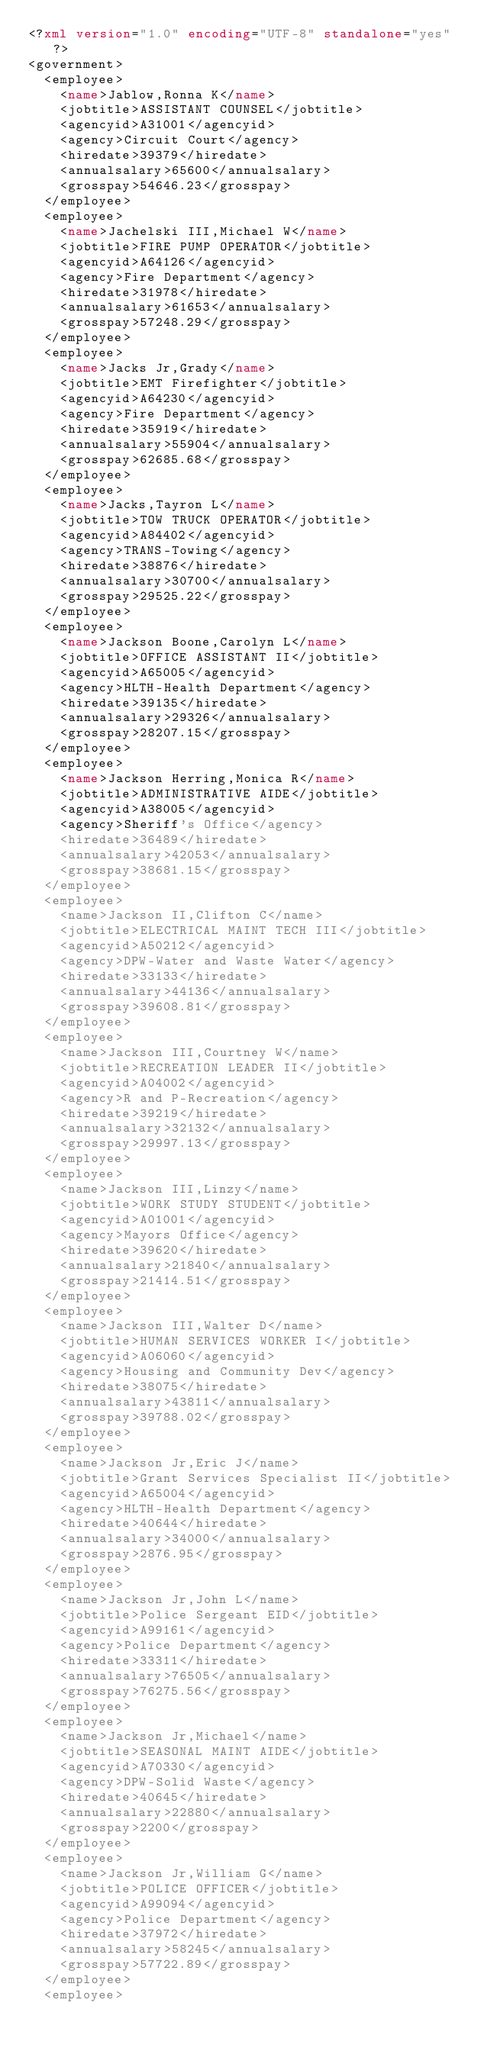Convert code to text. <code><loc_0><loc_0><loc_500><loc_500><_XML_><?xml version="1.0" encoding="UTF-8" standalone="yes"?>
<government>
	<employee>
		<name>Jablow,Ronna K</name>
		<jobtitle>ASSISTANT COUNSEL</jobtitle>
		<agencyid>A31001</agencyid>
		<agency>Circuit Court</agency>
		<hiredate>39379</hiredate>
		<annualsalary>65600</annualsalary>
		<grosspay>54646.23</grosspay>
	</employee>
	<employee>
		<name>Jachelski III,Michael W</name>
		<jobtitle>FIRE PUMP OPERATOR</jobtitle>
		<agencyid>A64126</agencyid>
		<agency>Fire Department</agency>
		<hiredate>31978</hiredate>
		<annualsalary>61653</annualsalary>
		<grosspay>57248.29</grosspay>
	</employee>
	<employee>
		<name>Jacks Jr,Grady</name>
		<jobtitle>EMT Firefighter</jobtitle>
		<agencyid>A64230</agencyid>
		<agency>Fire Department</agency>
		<hiredate>35919</hiredate>
		<annualsalary>55904</annualsalary>
		<grosspay>62685.68</grosspay>
	</employee>
	<employee>
		<name>Jacks,Tayron L</name>
		<jobtitle>TOW TRUCK OPERATOR</jobtitle>
		<agencyid>A84402</agencyid>
		<agency>TRANS-Towing</agency>
		<hiredate>38876</hiredate>
		<annualsalary>30700</annualsalary>
		<grosspay>29525.22</grosspay>
	</employee>
	<employee>
		<name>Jackson Boone,Carolyn L</name>
		<jobtitle>OFFICE ASSISTANT II</jobtitle>
		<agencyid>A65005</agencyid>
		<agency>HLTH-Health Department</agency>
		<hiredate>39135</hiredate>
		<annualsalary>29326</annualsalary>
		<grosspay>28207.15</grosspay>
	</employee>
	<employee>
		<name>Jackson Herring,Monica R</name>
		<jobtitle>ADMINISTRATIVE AIDE</jobtitle>
		<agencyid>A38005</agencyid>
		<agency>Sheriff's Office</agency>
		<hiredate>36489</hiredate>
		<annualsalary>42053</annualsalary>
		<grosspay>38681.15</grosspay>
	</employee>
	<employee>
		<name>Jackson II,Clifton C</name>
		<jobtitle>ELECTRICAL MAINT TECH III</jobtitle>
		<agencyid>A50212</agencyid>
		<agency>DPW-Water and Waste Water</agency>
		<hiredate>33133</hiredate>
		<annualsalary>44136</annualsalary>
		<grosspay>39608.81</grosspay>
	</employee>
	<employee>
		<name>Jackson III,Courtney W</name>
		<jobtitle>RECREATION LEADER II</jobtitle>
		<agencyid>A04002</agencyid>
		<agency>R and P-Recreation</agency>
		<hiredate>39219</hiredate>
		<annualsalary>32132</annualsalary>
		<grosspay>29997.13</grosspay>
	</employee>
	<employee>
		<name>Jackson III,Linzy</name>
		<jobtitle>WORK STUDY STUDENT</jobtitle>
		<agencyid>A01001</agencyid>
		<agency>Mayors Office</agency>
		<hiredate>39620</hiredate>
		<annualsalary>21840</annualsalary>
		<grosspay>21414.51</grosspay>
	</employee>
	<employee>
		<name>Jackson III,Walter D</name>
		<jobtitle>HUMAN SERVICES WORKER I</jobtitle>
		<agencyid>A06060</agencyid>
		<agency>Housing and Community Dev</agency>
		<hiredate>38075</hiredate>
		<annualsalary>43811</annualsalary>
		<grosspay>39788.02</grosspay>
	</employee>
	<employee>
		<name>Jackson Jr,Eric J</name>
		<jobtitle>Grant Services Specialist II</jobtitle>
		<agencyid>A65004</agencyid>
		<agency>HLTH-Health Department</agency>
		<hiredate>40644</hiredate>
		<annualsalary>34000</annualsalary>
		<grosspay>2876.95</grosspay>
	</employee>
	<employee>
		<name>Jackson Jr,John L</name>
		<jobtitle>Police Sergeant EID</jobtitle>
		<agencyid>A99161</agencyid>
		<agency>Police Department</agency>
		<hiredate>33311</hiredate>
		<annualsalary>76505</annualsalary>
		<grosspay>76275.56</grosspay>
	</employee>
	<employee>
		<name>Jackson Jr,Michael</name>
		<jobtitle>SEASONAL MAINT AIDE</jobtitle>
		<agencyid>A70330</agencyid>
		<agency>DPW-Solid Waste</agency>
		<hiredate>40645</hiredate>
		<annualsalary>22880</annualsalary>
		<grosspay>2200</grosspay>
	</employee>
	<employee>
		<name>Jackson Jr,William G</name>
		<jobtitle>POLICE OFFICER</jobtitle>
		<agencyid>A99094</agencyid>
		<agency>Police Department</agency>
		<hiredate>37972</hiredate>
		<annualsalary>58245</annualsalary>
		<grosspay>57722.89</grosspay>
	</employee>
	<employee></code> 